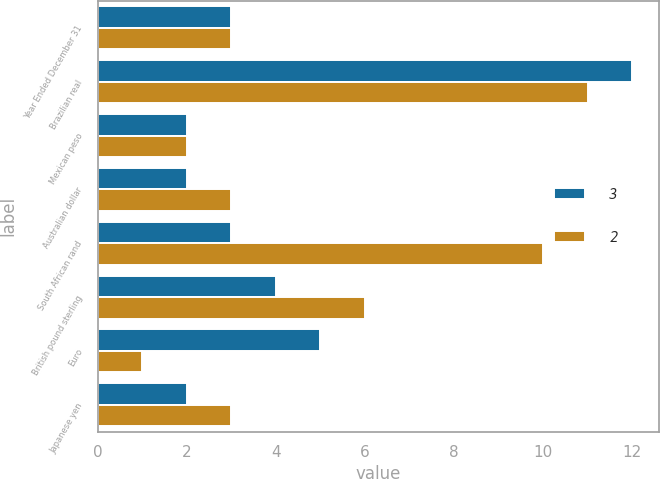Convert chart to OTSL. <chart><loc_0><loc_0><loc_500><loc_500><stacked_bar_chart><ecel><fcel>Year Ended December 31<fcel>Brazilian real<fcel>Mexican peso<fcel>Australian dollar<fcel>South African rand<fcel>British pound sterling<fcel>Euro<fcel>Japanese yen<nl><fcel>3<fcel>3<fcel>12<fcel>2<fcel>2<fcel>3<fcel>4<fcel>5<fcel>2<nl><fcel>2<fcel>3<fcel>11<fcel>2<fcel>3<fcel>10<fcel>6<fcel>1<fcel>3<nl></chart> 